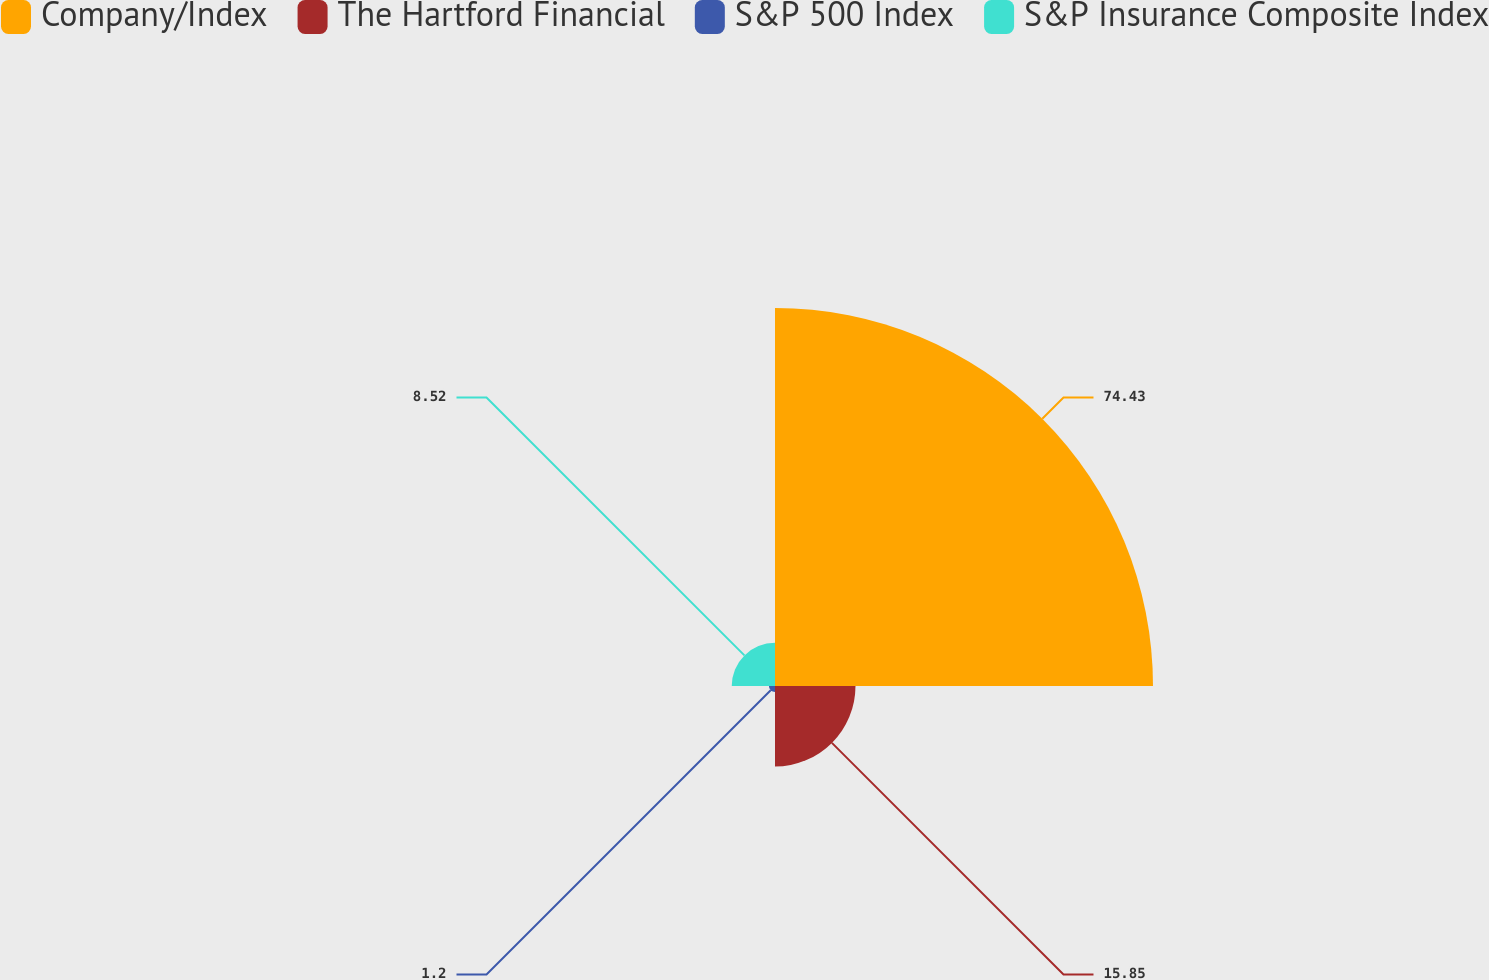Convert chart to OTSL. <chart><loc_0><loc_0><loc_500><loc_500><pie_chart><fcel>Company/Index<fcel>The Hartford Financial<fcel>S&P 500 Index<fcel>S&P Insurance Composite Index<nl><fcel>74.44%<fcel>15.85%<fcel>1.2%<fcel>8.52%<nl></chart> 